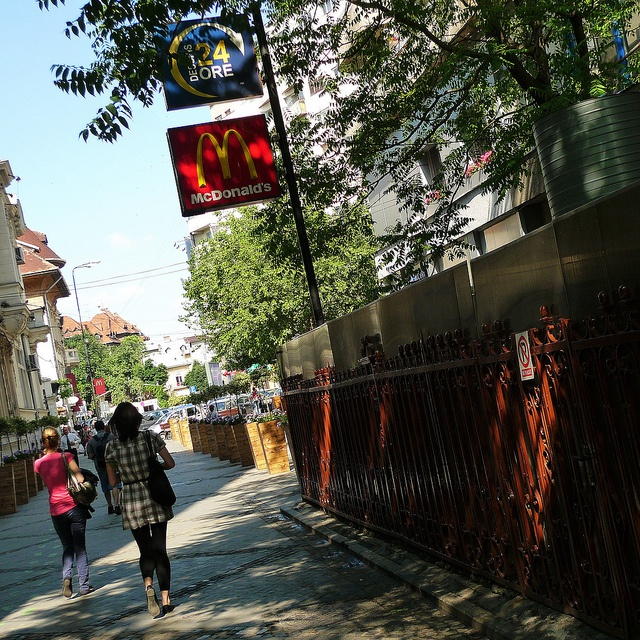Describe the objects in this image and their specific colors. I can see people in lightblue, black, gray, and maroon tones, people in lightblue, black, maroon, gray, and brown tones, people in lightblue, black, gray, purple, and darkblue tones, handbag in lightblue, black, and gray tones, and handbag in lightblue, black, gray, and tan tones in this image. 